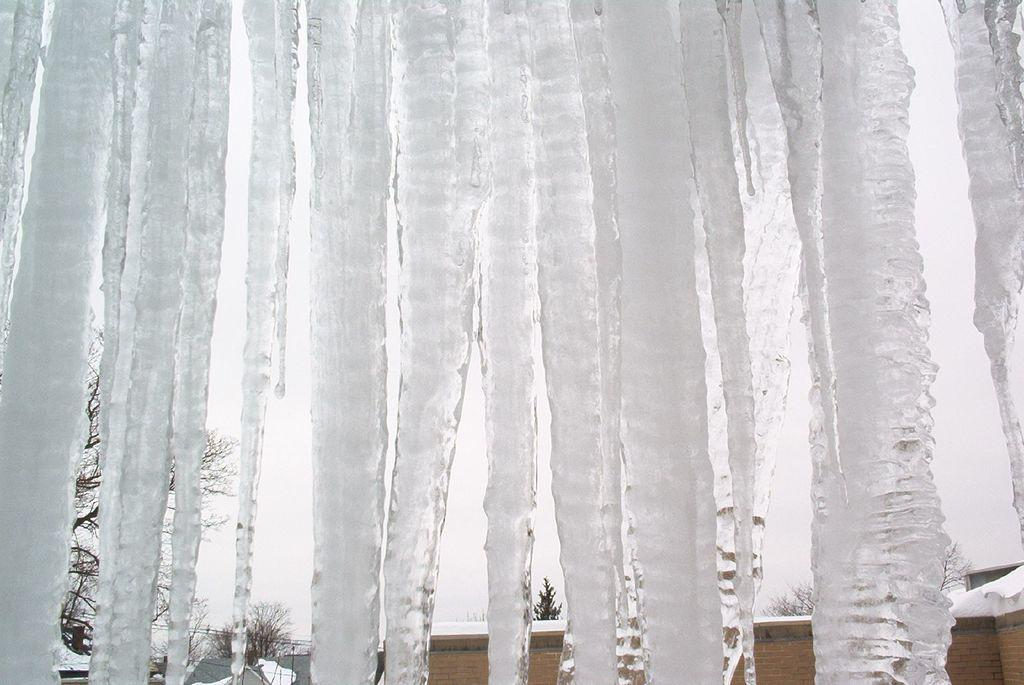What is in the foreground of the image? There is ice water in the foreground of the image. What can be seen in the background of the image? There is snow, trees, and buildings in the background of the image. How many different types of natural elements are visible in the background? There are two different types of natural elements visible in the background: snow and trees. What type of structures can be seen in the background? There are buildings in the background of the image. What is the temperature of the fight between the trees and the buildings in the image? There is no fight between the trees and the buildings in the image, and therefore no temperature can be associated with it. 